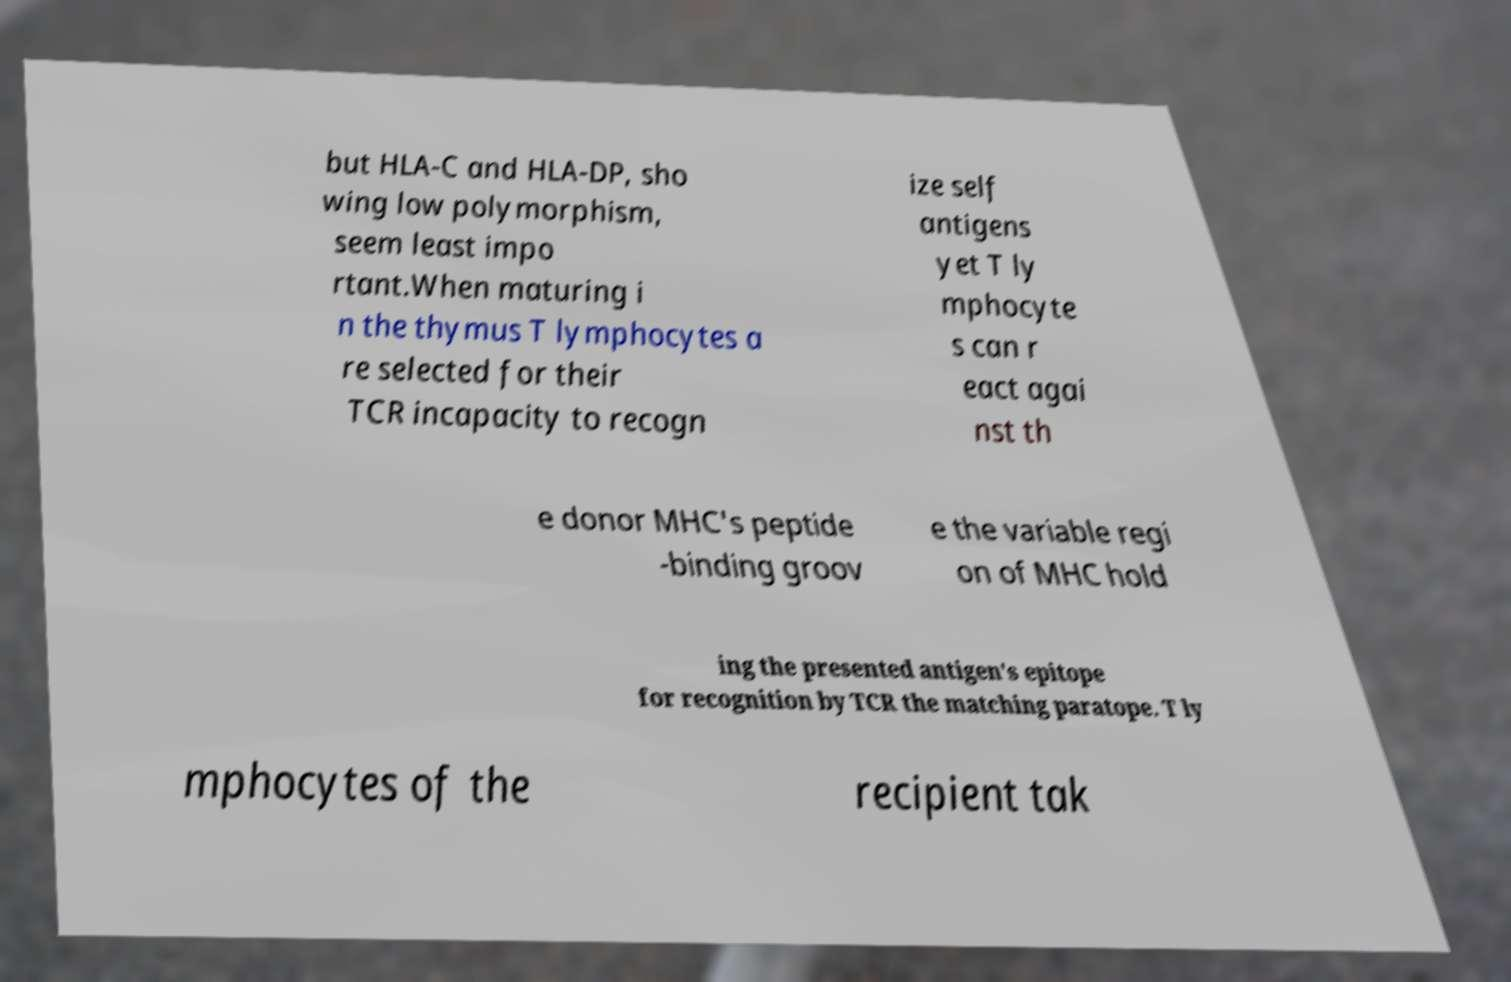Can you read and provide the text displayed in the image?This photo seems to have some interesting text. Can you extract and type it out for me? but HLA-C and HLA-DP, sho wing low polymorphism, seem least impo rtant.When maturing i n the thymus T lymphocytes a re selected for their TCR incapacity to recogn ize self antigens yet T ly mphocyte s can r eact agai nst th e donor MHC's peptide -binding groov e the variable regi on of MHC hold ing the presented antigen's epitope for recognition by TCR the matching paratope. T ly mphocytes of the recipient tak 